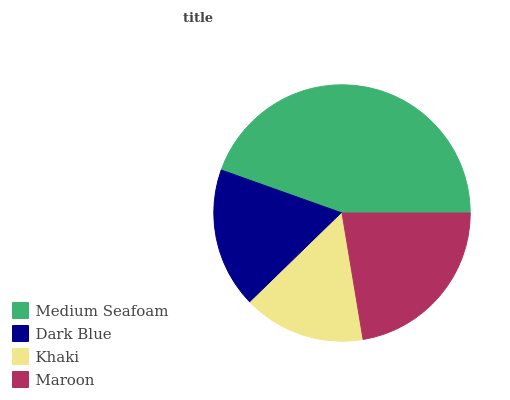Is Khaki the minimum?
Answer yes or no. Yes. Is Medium Seafoam the maximum?
Answer yes or no. Yes. Is Dark Blue the minimum?
Answer yes or no. No. Is Dark Blue the maximum?
Answer yes or no. No. Is Medium Seafoam greater than Dark Blue?
Answer yes or no. Yes. Is Dark Blue less than Medium Seafoam?
Answer yes or no. Yes. Is Dark Blue greater than Medium Seafoam?
Answer yes or no. No. Is Medium Seafoam less than Dark Blue?
Answer yes or no. No. Is Maroon the high median?
Answer yes or no. Yes. Is Dark Blue the low median?
Answer yes or no. Yes. Is Medium Seafoam the high median?
Answer yes or no. No. Is Medium Seafoam the low median?
Answer yes or no. No. 